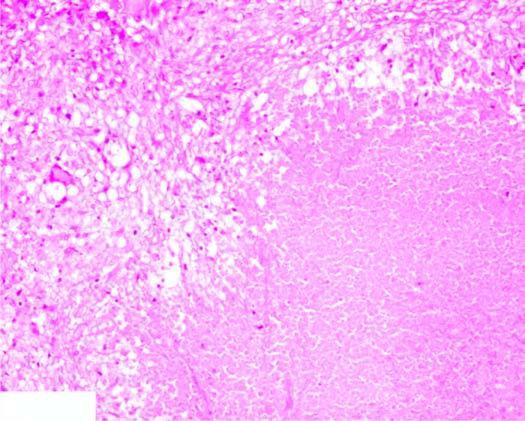does the surrounding zone show granulomatous inflammation?
Answer the question using a single word or phrase. No 